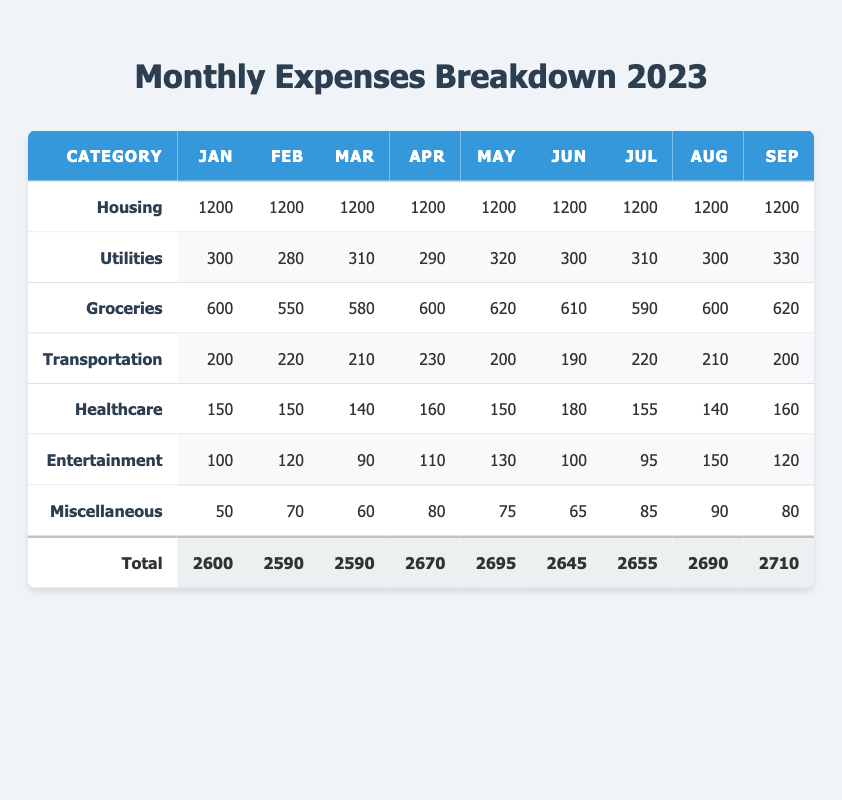What is the total spending on Housing for the year? To find the total spending on Housing, I look at the values in the Housing row for each month. They are all 1200, so I multiply 1200 by 12 (months) to get 14400.
Answer: 14400 Which month had the highest spending on Transportation? I compare the values in the Transportation row across all months. The highest value appears in December with 250.
Answer: 250 What is the average monthly expenditure on Utilities? To calculate the average, I will sum the expenditures in the Utilities row for all months: (300 + 280 + 310 + 290 + 320 + 300 + 310 + 300 + 330 + 300 + 310 + 290) = 3640, and then divide by 12, which gives 3640/12 = 303.33.
Answer: 303.33 Did the spending on Entertainment exceed 150 in any month? I will check the Entertainment row for each month: values are 100, 120, 90, 110, 130, 100, 95, 150, 120, 110, 140, and 200. The value exceeded 150 in December, which is 200. Thus, the answer is yes.
Answer: Yes What was the total spending on Groceries for the first half of the year (January to June)? I look at the Groceries row from January to June: 600, 550, 580, 600, 620, and 610. The sum is (600 + 550 + 580 + 600 + 620 + 610) = 3560.
Answer: 3560 Which month had the least spending on Utilities? In the Utilities row, the values are 300, 280, 310, 290, 320, 300, 310, 300, 330, 300, 310, and 290. The least spending occurred in February with a value of 280.
Answer: 280 Is the total spending on Miscellaneous greater than the total for Healthcare? The total spending on Miscellaneous is 910 (sum up the values in the row), and for Healthcare, it is 1855. Since 910 is less than 1855, the answer is no.
Answer: No Calculate the percentage of the yearly spending that went to Housing. First, the total yearly spending is 31995 (found in the Total row). Now I calculate the percentage for Housing: (14400/31995) * 100 = 45.03%.
Answer: 45.03% What is the difference in spending between the highest and lowest month for Groceries? The highest spending on Groceries is in December (630) and the lowest is in February (550). I subtract the low from the high: 630 - 550 = 80.
Answer: 80 